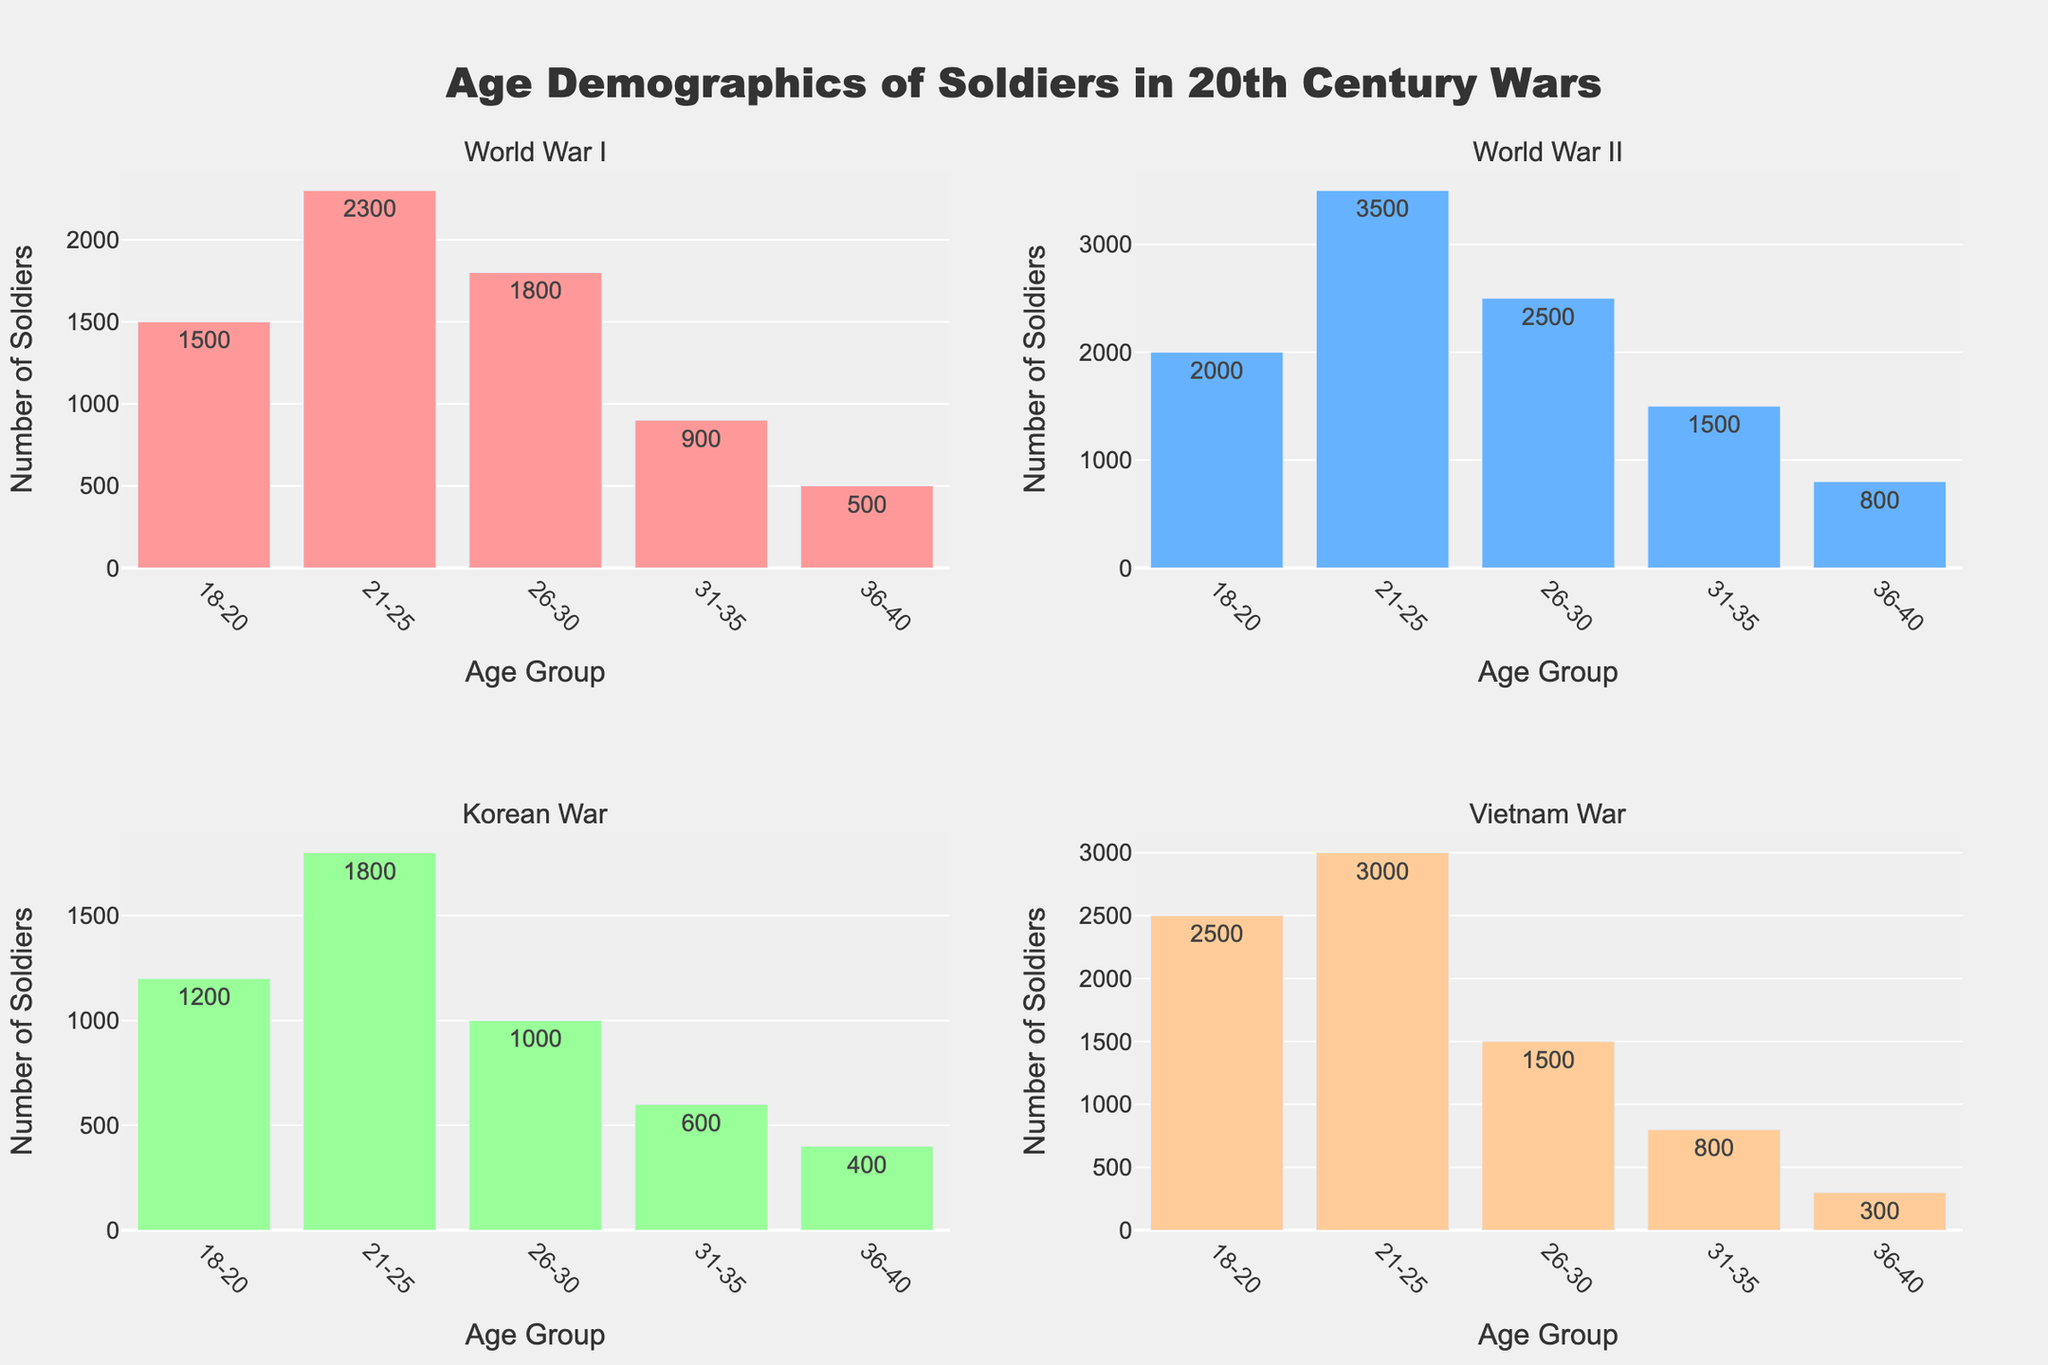Which war has the highest number of soldiers in the 21-25 age group? Look at the bars representing the 21-25 age group in each subplot. The tallest bar in this category represents World War II with 3500 soldiers.
Answer: World War II What is the total number of soldiers in the 18-20 age group across all wars? Add up the counts of soldiers in the 18-20 age group for each war: World War I (1500) + World War II (2000) + Korean War (1200) + Vietnam War (2500) = 7200 soldiers.
Answer: 7200 Which age group has the lowest number of soldiers in the Korean War? In the Korean War subplot, the shortest bar represents the 36-40 age group with 400 soldiers.
Answer: 36-40 Compare the number of soldiers aged 26-30 in World War I and the Vietnam War. Which war had more soldiers in this age range? Compare the height of the bars for the 26-30 age group in World War I (1800 soldiers) and the Vietnam War (1500 soldiers). World War I had more soldiers in this age range.
Answer: World War I In which war is the distribution of soldiers most skewed towards younger age groups (18-25)? Compare the first two bars (18-20 and 21-25 age groups) in each subplot. The most skewed distribution towards younger age groups is in the Vietnam War, with 2500 soldiers aged 18-20 and 3000 soldiers aged 21-25.
Answer: Vietnam War What is the sum of soldiers aged 31-35 and 36-40 in World War II? Add the counts for the 31-35 and 36-40 age groups in World War II: 1500 + 800 = 2300 soldiers.
Answer: 2300 Which war has the most even distribution of soldiers across all age groups? Look at the relative heights of the bars within each subplot. The Korean War has the most even distribution as the differences between bars are less pronounced.
Answer: Korean War How many more soldiers aged 26-30 were there in World War II compared to the Korean War? Subtract the number of soldiers aged 26-30 in the Korean War (1000) from the number in World War II (2500): 2500 - 1000 = 1500 more soldiers.
Answer: 1500 Which age group saw the most significant increase in the number of soldiers from World War I to World War II? Compare the differences in the height of each age group's bars between World War I and World War II. The 21-25 age group increased the most from 2300 to 3500 soldiers, a difference of 1200.
Answer: 21-25 